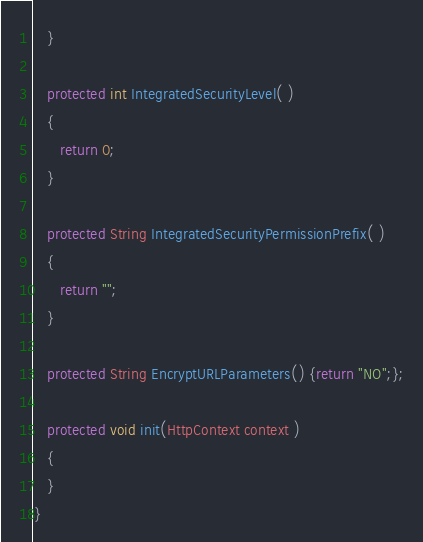Convert code to text. <code><loc_0><loc_0><loc_500><loc_500><_Java_>   }	

   protected int IntegratedSecurityLevel( )
   {
      return 0;
   }   
   
   protected String IntegratedSecurityPermissionPrefix( )
   {
      return "";
   }

   protected String EncryptURLParameters() {return "NO";};
   
   protected void init(HttpContext context )
   {
   }      
}
</code> 